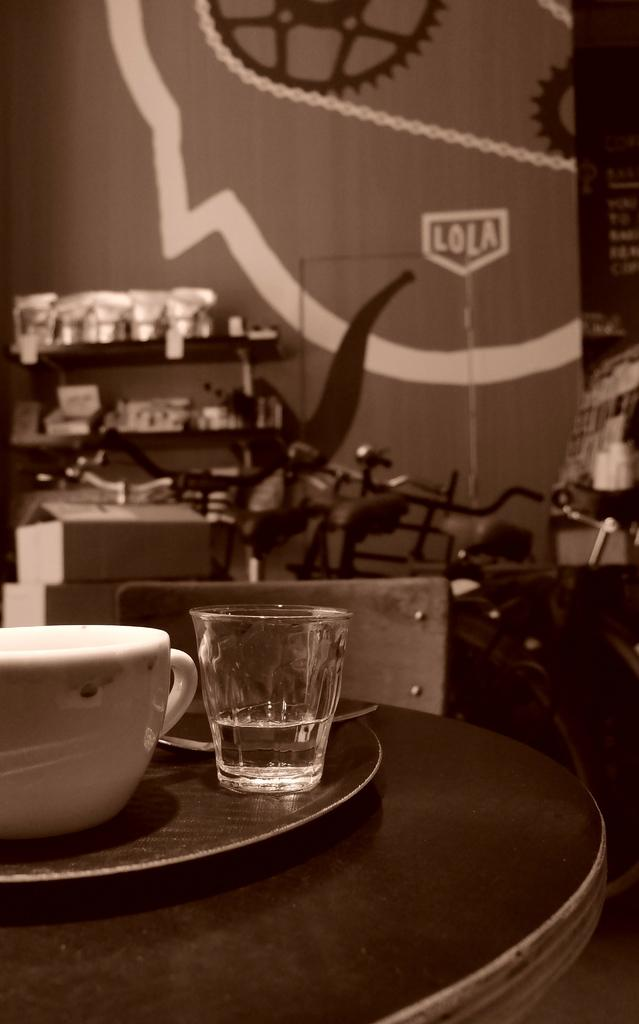What object is present in the image that can hold multiple items? There is a tray in the image that can hold multiple items. What type of container is on the tray? There is a cup on the tray. What other type of container is on the tray? There is a glass on the tray. What color scheme is used in the image? The image is in black and white color. Can you hear the bell ringing in the image? There is no bell present in the image, so it cannot be heard. 